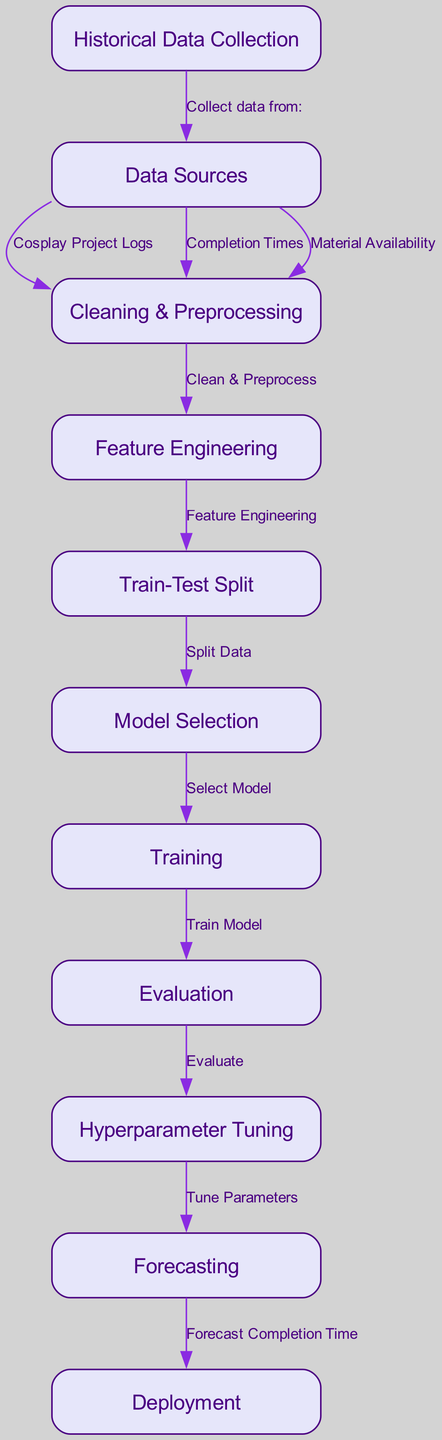What is the first step in the diagram? The first step is "Historical Data Collection," which is represented as the starting node of the flow.
Answer: Historical Data Collection How many nodes are present in the diagram? The diagram contains 11 nodes as listed in the nodes section of the provided data.
Answer: 11 What does the edge from "evaluation" to "hyperparameter_tuning" represent? This edge shows the relationship that after the evaluation phase, the model moves to hyperparameter tuning based on the evaluation results.
Answer: Evaluate Which node is responsible for splitting the data? The "Train-Test Split" node is responsible for the data splitting process in the workflow.
Answer: Train-Test Split What type of data is initially collected from "data_sources"? "Cosplay Project Logs," "Completion Times," and "Material Availability" are collected from the data sources as indicated by the connections from "data_sources" to "cleaning_preprocessing."
Answer: Cosplay Project Logs, Completion Times, Material Availability Which node follows "feature_engineering" in the diagram? The next node after "feature_engineering" is "train_test_split," which indicates that after feature engineering, the data is split for training and testing.
Answer: Train-Test Split What is the final outcome of the diagram? The final outcome is "Forecast Completion Time," which indicates the goal of the entire process after training and evaluation.
Answer: Forecast Completion Time What action is performed in the "training" node? The action performed in the "training" node is "Train Model," which signifies that the model is being trained with the prepared data.
Answer: Train Model What does the "model_selection" node rely on for its operation? The "model_selection" node relies on the results from the "train_test_split" phase, as it selects a model based on the split data.
Answer: Train-Test Split What is indicated by the arrow leading from "forecasting" to "deployment"? The arrow indicates that after the forecasting of completion times, the results are deployed, implying that the model's predictions are put into use.
Answer: Forecast Completion Time 